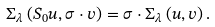<formula> <loc_0><loc_0><loc_500><loc_500>\Sigma _ { \lambda } \left ( S _ { 0 } u , \sigma \cdot v \right ) = \sigma \cdot \Sigma _ { \lambda } \left ( u , v \right ) .</formula> 